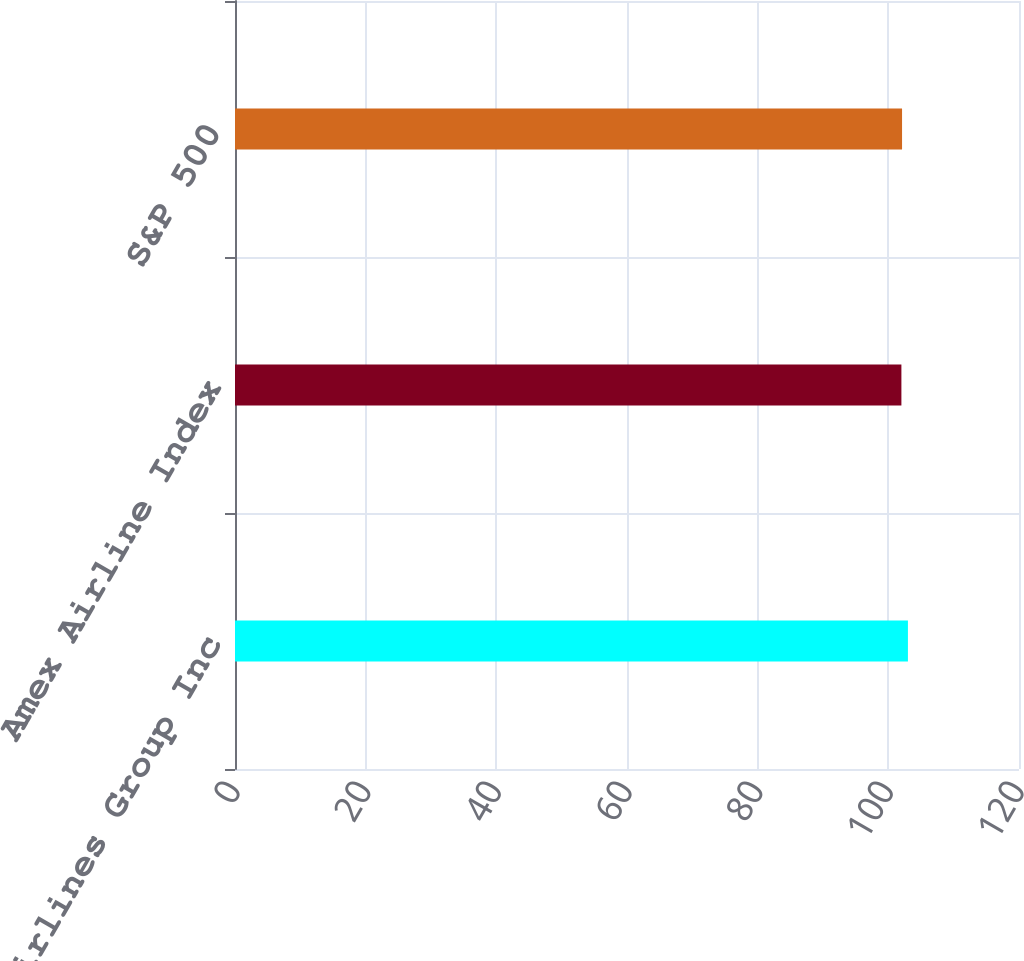<chart> <loc_0><loc_0><loc_500><loc_500><bar_chart><fcel>American Airlines Group Inc<fcel>Amex Airline Index<fcel>S&P 500<nl><fcel>103<fcel>102<fcel>102.1<nl></chart> 